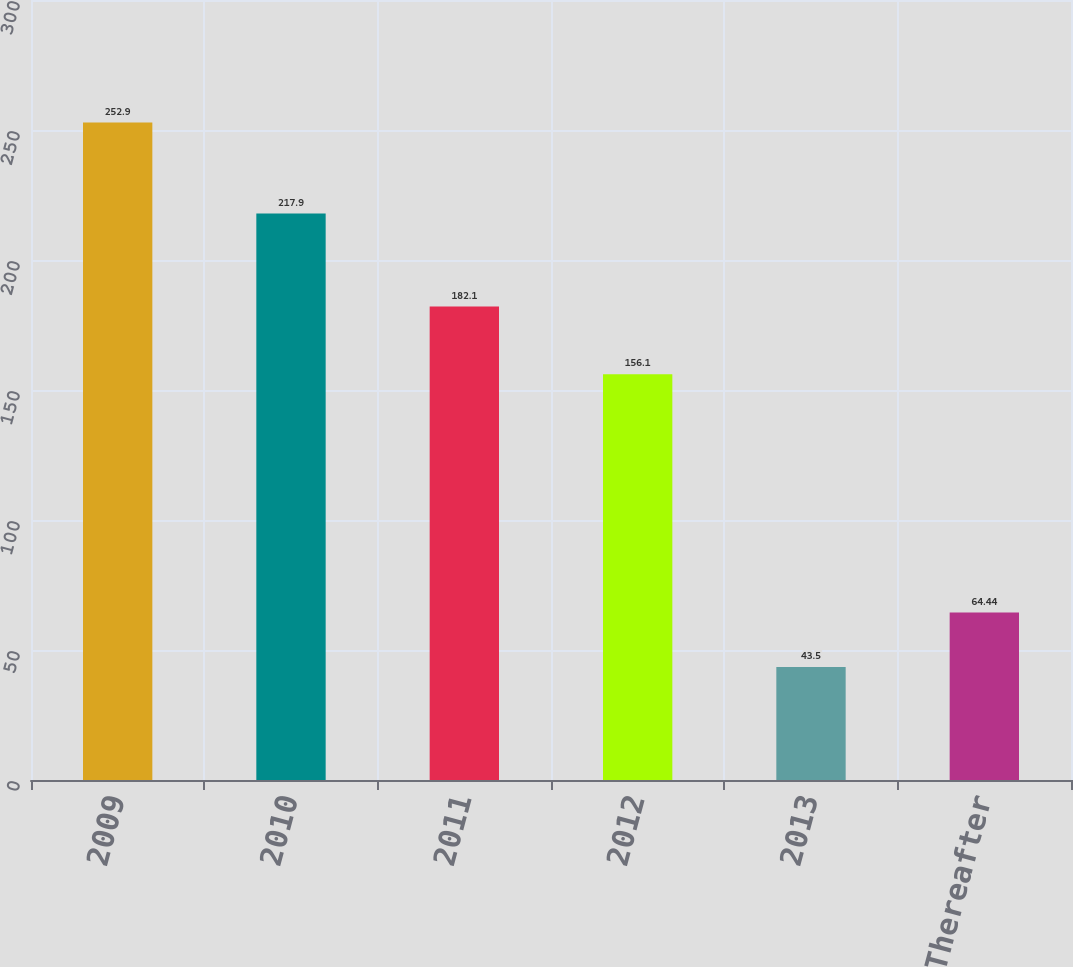Convert chart to OTSL. <chart><loc_0><loc_0><loc_500><loc_500><bar_chart><fcel>2009<fcel>2010<fcel>2011<fcel>2012<fcel>2013<fcel>Thereafter<nl><fcel>252.9<fcel>217.9<fcel>182.1<fcel>156.1<fcel>43.5<fcel>64.44<nl></chart> 